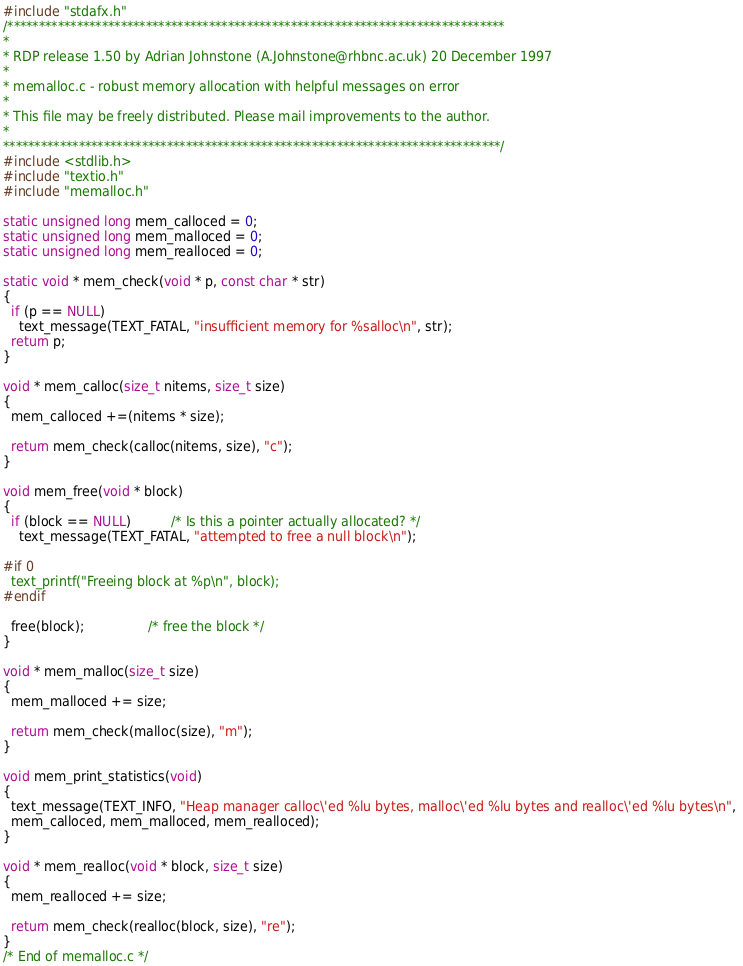<code> <loc_0><loc_0><loc_500><loc_500><_C_>#include "stdafx.h"
/*******************************************************************************
*
* RDP release 1.50 by Adrian Johnstone (A.Johnstone@rhbnc.ac.uk) 20 December 1997
*
* memalloc.c - robust memory allocation with helpful messages on error
*
* This file may be freely distributed. Please mail improvements to the author.
*
*******************************************************************************/
#include <stdlib.h>
#include "textio.h"
#include "memalloc.h"

static unsigned long mem_calloced = 0; 
static unsigned long mem_malloced = 0; 
static unsigned long mem_realloced = 0; 

static void * mem_check(void * p, const char * str)
{
  if (p == NULL)
    text_message(TEXT_FATAL, "insufficient memory for %salloc\n", str); 
  return p; 
}

void * mem_calloc(size_t nitems, size_t size)
{
  mem_calloced +=(nitems * size); 
  
  return mem_check(calloc(nitems, size), "c"); 
}

void mem_free(void * block)
{
  if (block == NULL)          /* Is this a pointer actually allocated? */
    text_message(TEXT_FATAL, "attempted to free a null block\n"); 

#if 0
  text_printf("Freeing block at %p\n", block);
#endif

  free(block);                /* free the block */
}

void * mem_malloc(size_t size)
{
  mem_malloced += size; 
  
  return mem_check(malloc(size), "m"); 
}

void mem_print_statistics(void)
{
  text_message(TEXT_INFO, "Heap manager calloc\'ed %lu bytes, malloc\'ed %lu bytes and realloc\'ed %lu bytes\n", 
  mem_calloced, mem_malloced, mem_realloced); 
}

void * mem_realloc(void * block, size_t size)
{
  mem_realloced += size; 
  
  return mem_check(realloc(block, size), "re"); 
}
/* End of memalloc.c */
</code> 